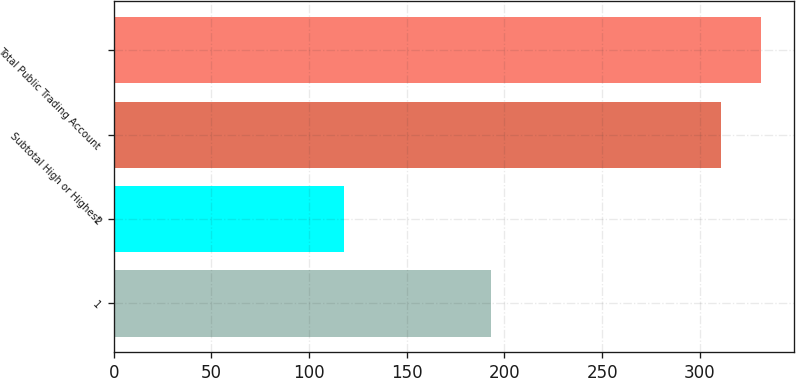<chart> <loc_0><loc_0><loc_500><loc_500><bar_chart><fcel>1<fcel>2<fcel>Subtotal High or Highest<fcel>Total Public Trading Account<nl><fcel>193<fcel>118<fcel>311<fcel>331.5<nl></chart> 